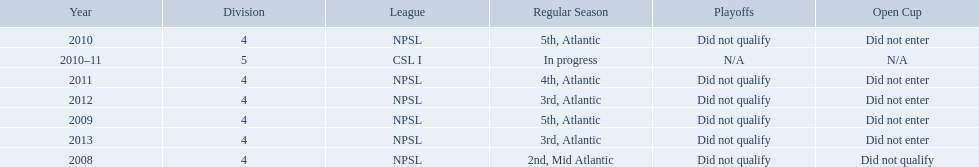What are the leagues? NPSL, NPSL, NPSL, CSL I, NPSL, NPSL, NPSL. Of these, what league is not npsl? CSL I. 